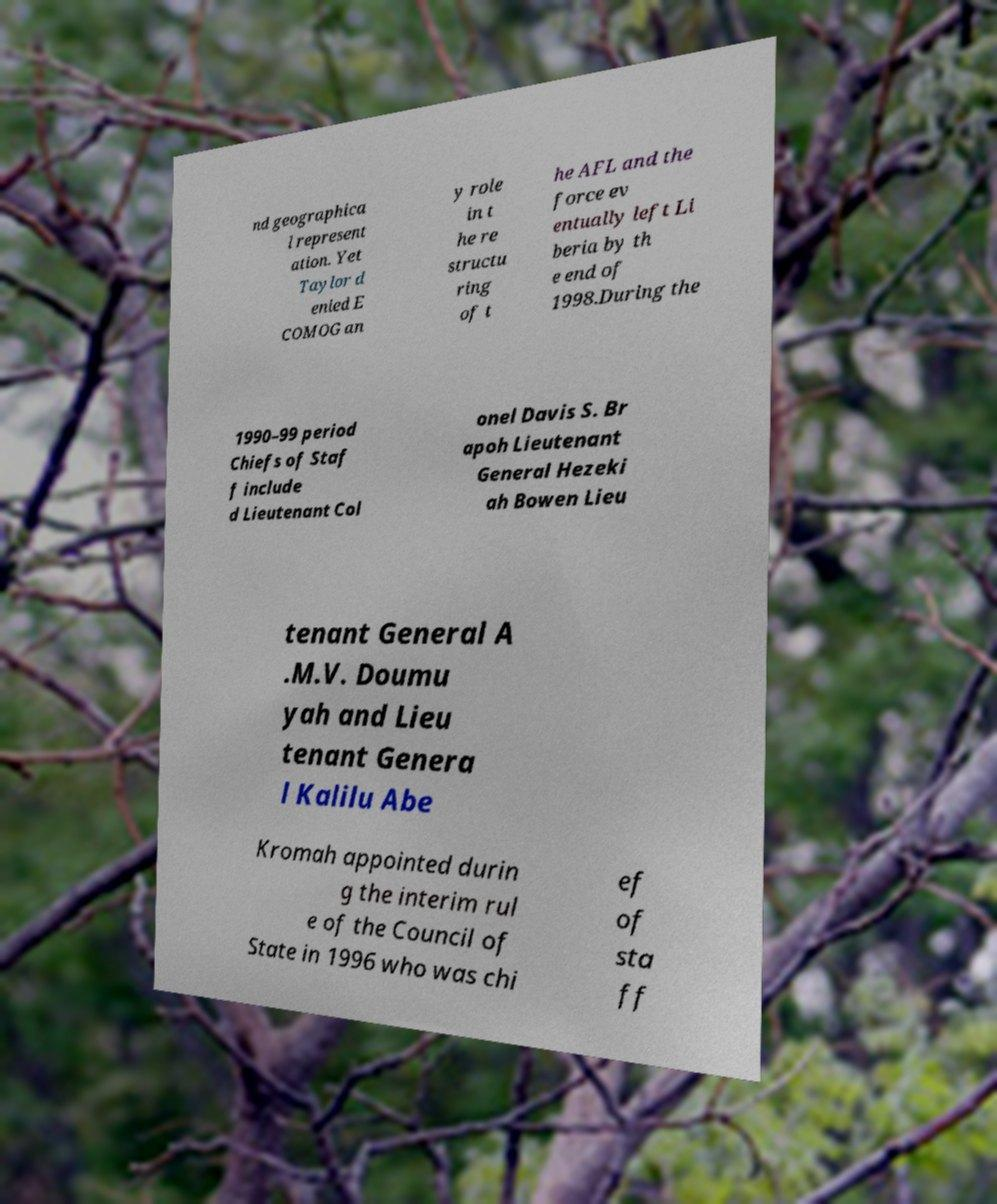Could you assist in decoding the text presented in this image and type it out clearly? nd geographica l represent ation. Yet Taylor d enied E COMOG an y role in t he re structu ring of t he AFL and the force ev entually left Li beria by th e end of 1998.During the 1990–99 period Chiefs of Staf f include d Lieutenant Col onel Davis S. Br apoh Lieutenant General Hezeki ah Bowen Lieu tenant General A .M.V. Doumu yah and Lieu tenant Genera l Kalilu Abe Kromah appointed durin g the interim rul e of the Council of State in 1996 who was chi ef of sta ff 